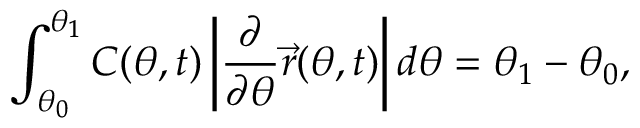<formula> <loc_0><loc_0><loc_500><loc_500>\int _ { \theta _ { 0 } } ^ { \theta _ { 1 } } { C ( \theta , t ) \left | \frac { \partial } { \partial \theta } \vec { r } ( \theta , t ) \right | d \theta } = \theta _ { 1 } - \theta _ { 0 } ,</formula> 